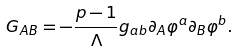<formula> <loc_0><loc_0><loc_500><loc_500>G _ { A B } = - \frac { p - 1 } { \Lambda } g _ { a b } \partial _ { A } \varphi ^ { a } \partial _ { B } \varphi ^ { b } .</formula> 